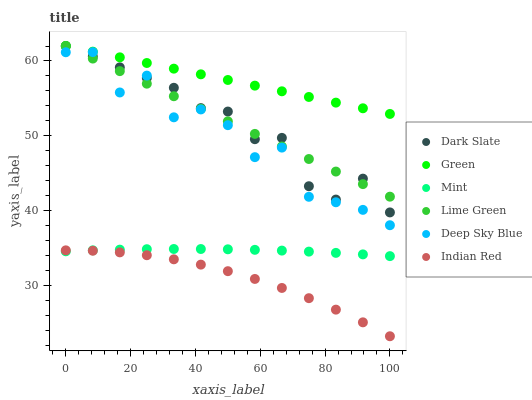Does Indian Red have the minimum area under the curve?
Answer yes or no. Yes. Does Green have the maximum area under the curve?
Answer yes or no. Yes. Does Lime Green have the minimum area under the curve?
Answer yes or no. No. Does Lime Green have the maximum area under the curve?
Answer yes or no. No. Is Green the smoothest?
Answer yes or no. Yes. Is Deep Sky Blue the roughest?
Answer yes or no. Yes. Is Lime Green the smoothest?
Answer yes or no. No. Is Lime Green the roughest?
Answer yes or no. No. Does Indian Red have the lowest value?
Answer yes or no. Yes. Does Lime Green have the lowest value?
Answer yes or no. No. Does Green have the highest value?
Answer yes or no. Yes. Does Indian Red have the highest value?
Answer yes or no. No. Is Indian Red less than Dark Slate?
Answer yes or no. Yes. Is Dark Slate greater than Mint?
Answer yes or no. Yes. Does Indian Red intersect Mint?
Answer yes or no. Yes. Is Indian Red less than Mint?
Answer yes or no. No. Is Indian Red greater than Mint?
Answer yes or no. No. Does Indian Red intersect Dark Slate?
Answer yes or no. No. 